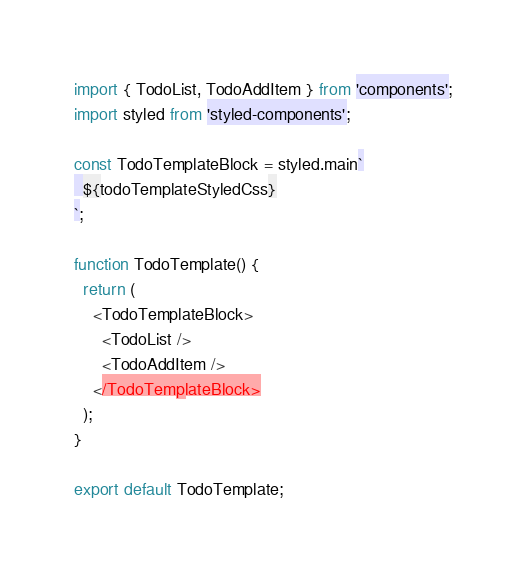Convert code to text. <code><loc_0><loc_0><loc_500><loc_500><_TypeScript_>import { TodoList, TodoAddItem } from 'components';
import styled from 'styled-components';

const TodoTemplateBlock = styled.main`
  ${todoTemplateStyledCss}
`;

function TodoTemplate() {
  return (
    <TodoTemplateBlock>
      <TodoList />
      <TodoAddItem />
    </TodoTemplateBlock>
  );
}

export default TodoTemplate;
</code> 